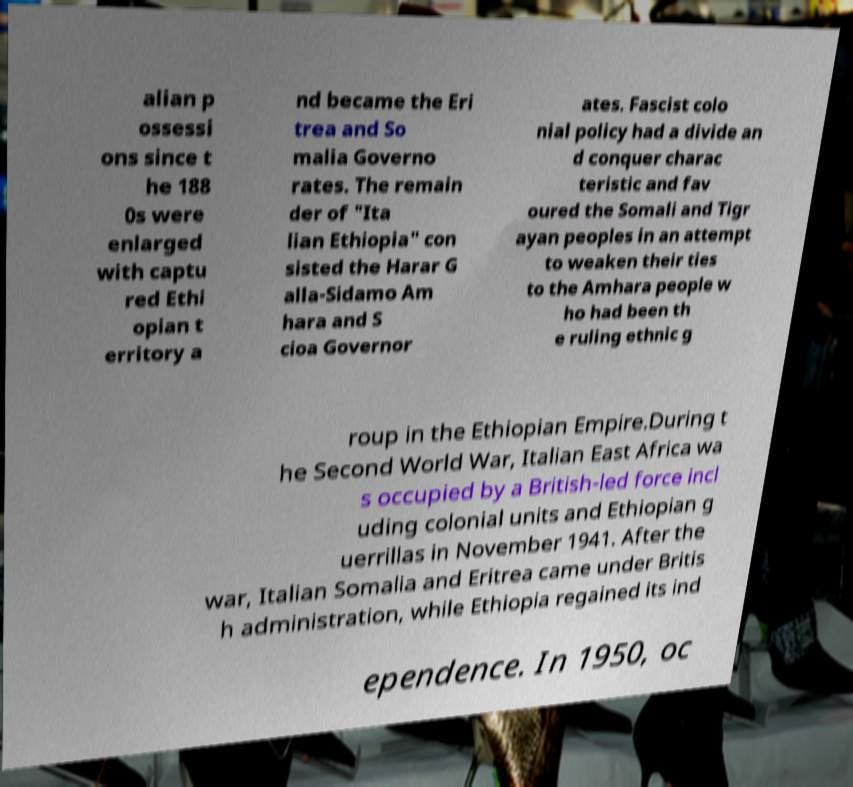Could you assist in decoding the text presented in this image and type it out clearly? alian p ossessi ons since t he 188 0s were enlarged with captu red Ethi opian t erritory a nd became the Eri trea and So malia Governo rates. The remain der of "Ita lian Ethiopia" con sisted the Harar G alla-Sidamo Am hara and S cioa Governor ates. Fascist colo nial policy had a divide an d conquer charac teristic and fav oured the Somali and Tigr ayan peoples in an attempt to weaken their ties to the Amhara people w ho had been th e ruling ethnic g roup in the Ethiopian Empire.During t he Second World War, Italian East Africa wa s occupied by a British-led force incl uding colonial units and Ethiopian g uerrillas in November 1941. After the war, Italian Somalia and Eritrea came under Britis h administration, while Ethiopia regained its ind ependence. In 1950, oc 